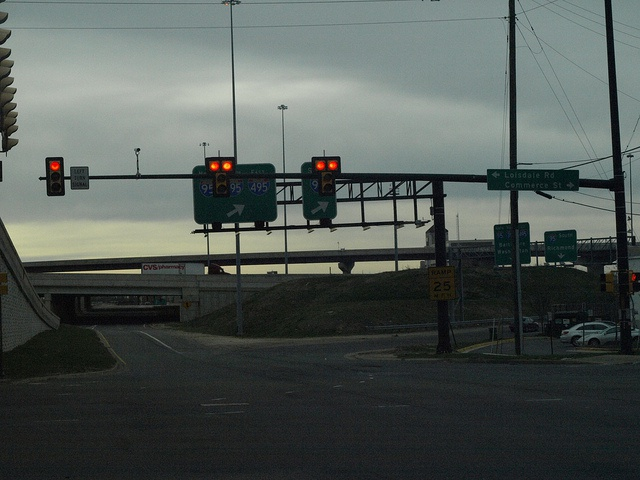Describe the objects in this image and their specific colors. I can see traffic light in black, darkgray, gray, and red tones, traffic light in black, red, and maroon tones, traffic light in black, maroon, red, and orange tones, car in black, gray, and purple tones, and car in black, teal, and purple tones in this image. 